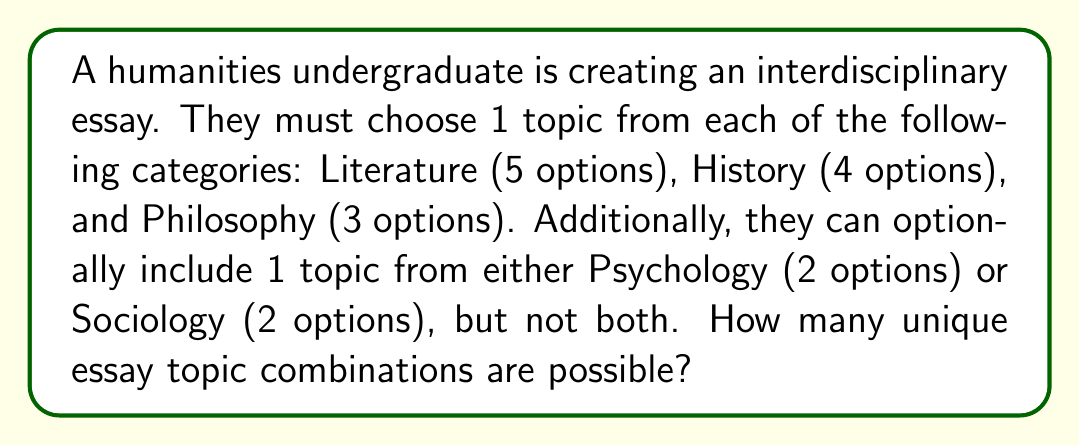Could you help me with this problem? Let's approach this step-by-step:

1) First, let's calculate the number of combinations without the optional category:
   - Literature: 5 choices
   - History: 4 choices
   - Philosophy: 3 choices
   
   Using the multiplication principle, we have:
   $5 \times 4 \times 3 = 60$ combinations

2) Now, let's consider the optional category:
   - The student can choose not to include an optional topic
   - Or they can choose 1 from Psychology (2 options)
   - Or they can choose 1 from Sociology (2 options)
   
   This gives us 1 + 2 + 2 = 5 possibilities for the optional category

3) To find the total number of combinations, we multiply the number of combinations without the optional category by the number of possibilities for the optional category:

   $60 \times 5 = 300$

Therefore, there are 300 unique essay topic combinations possible.
Answer: 300 